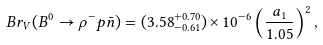<formula> <loc_0><loc_0><loc_500><loc_500>B r _ { V } ( B ^ { 0 } \to \rho ^ { - } p \bar { n } ) = ( 3 . 5 8 ^ { + 0 . 7 0 } _ { - 0 . 6 1 } ) \times 1 0 ^ { - 6 } \left ( \frac { a _ { 1 } } { 1 . 0 5 } \right ) ^ { 2 } ,</formula> 